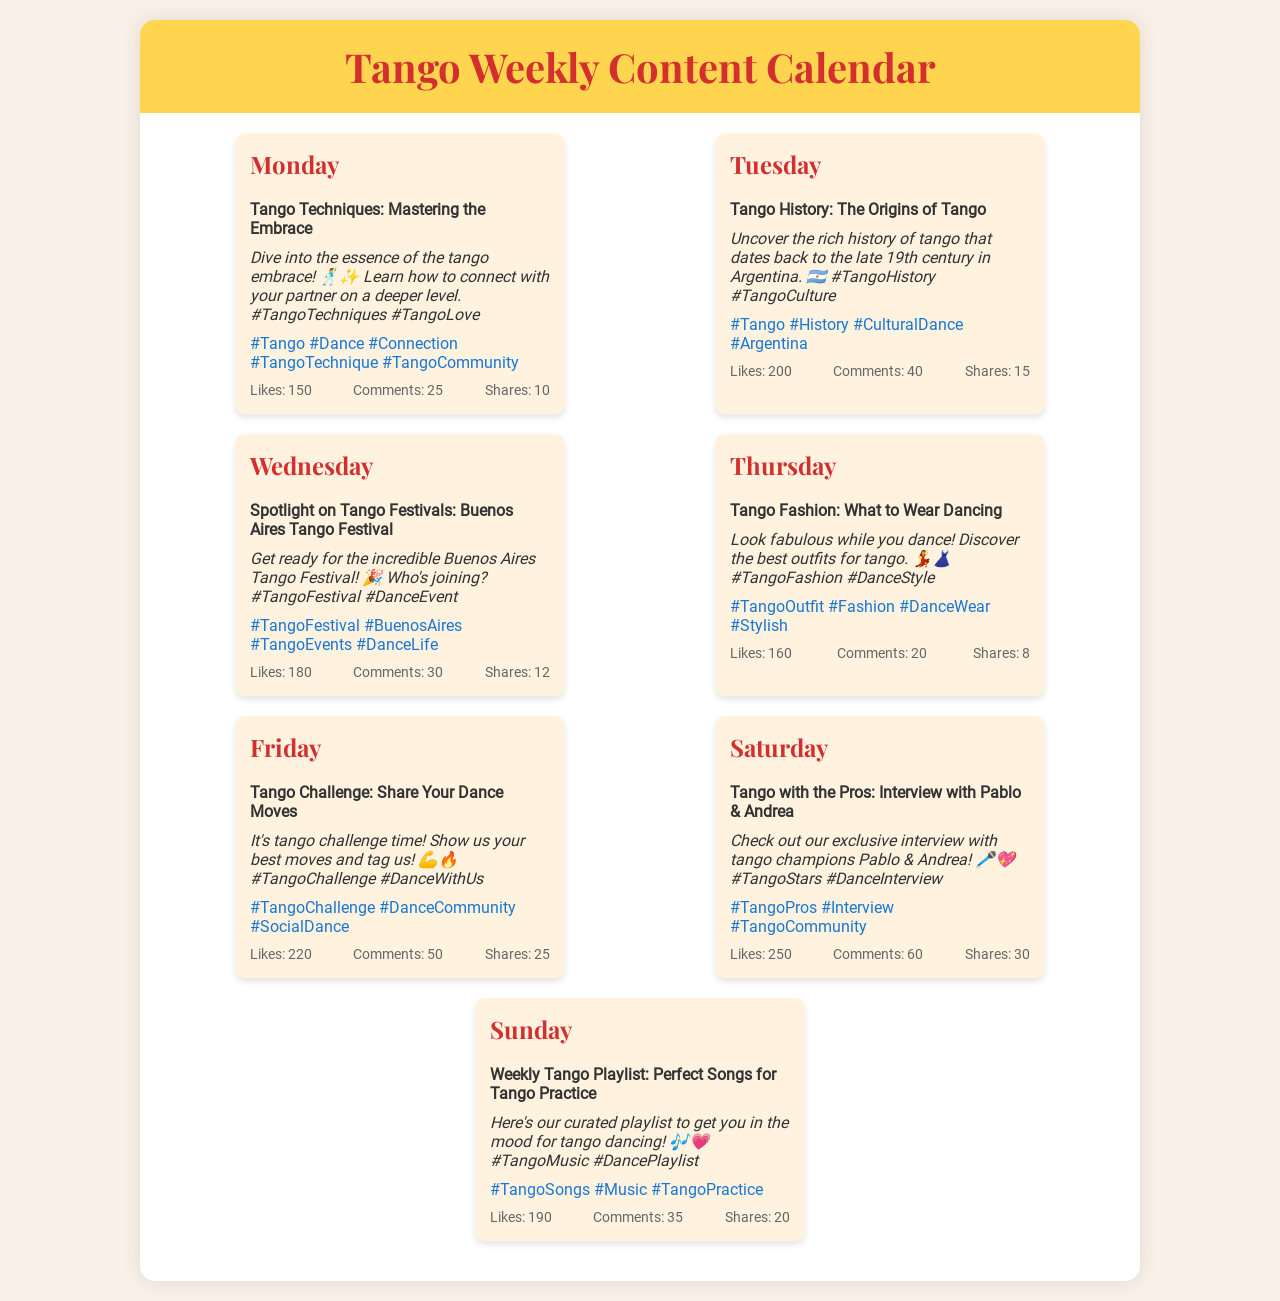What is the focus of Monday's post? Monday's post is about mastering the tango embrace.
Answer: Mastering the Embrace How many likes did the Friday post receive? The Friday post received 220 likes.
Answer: 220 What festival is highlighted on Wednesday? The Wednesday post spotlights the Buenos Aires Tango Festival.
Answer: Buenos Aires Tango Festival Which day features an interview with tango champions? Saturday features the interview with tango champions Pablo & Andrea.
Answer: Saturday What is the total number of shares for the Sunday post? The Sunday post had 20 shares.
Answer: 20 Which hashtag is associated with the style of clothing for tango? The hashtag associated with tango fashion is #TangoFashion.
Answer: #TangoFashion What is the main theme of Tuesday's post? Tuesday's post focuses on the origins of tango.
Answer: The Origins of Tango How many comments did the Thursday post receive? The Thursday post received 20 comments.
Answer: 20 What is the main activity proposed in the Friday post? The main activity proposed is sharing dance moves.
Answer: Share Your Dance Moves 